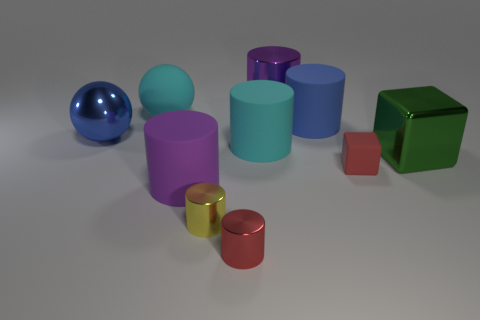Subtract all big metal cylinders. How many cylinders are left? 5 Subtract all blue cylinders. How many cylinders are left? 5 Subtract all balls. How many objects are left? 8 Subtract 1 cylinders. How many cylinders are left? 5 Add 3 large brown rubber cubes. How many large brown rubber cubes exist? 3 Subtract 0 purple spheres. How many objects are left? 10 Subtract all blue spheres. Subtract all green cylinders. How many spheres are left? 1 Subtract all gray cubes. How many gray spheres are left? 0 Subtract all big purple rubber objects. Subtract all small red metallic cylinders. How many objects are left? 8 Add 8 big purple cylinders. How many big purple cylinders are left? 10 